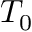<formula> <loc_0><loc_0><loc_500><loc_500>T _ { 0 }</formula> 